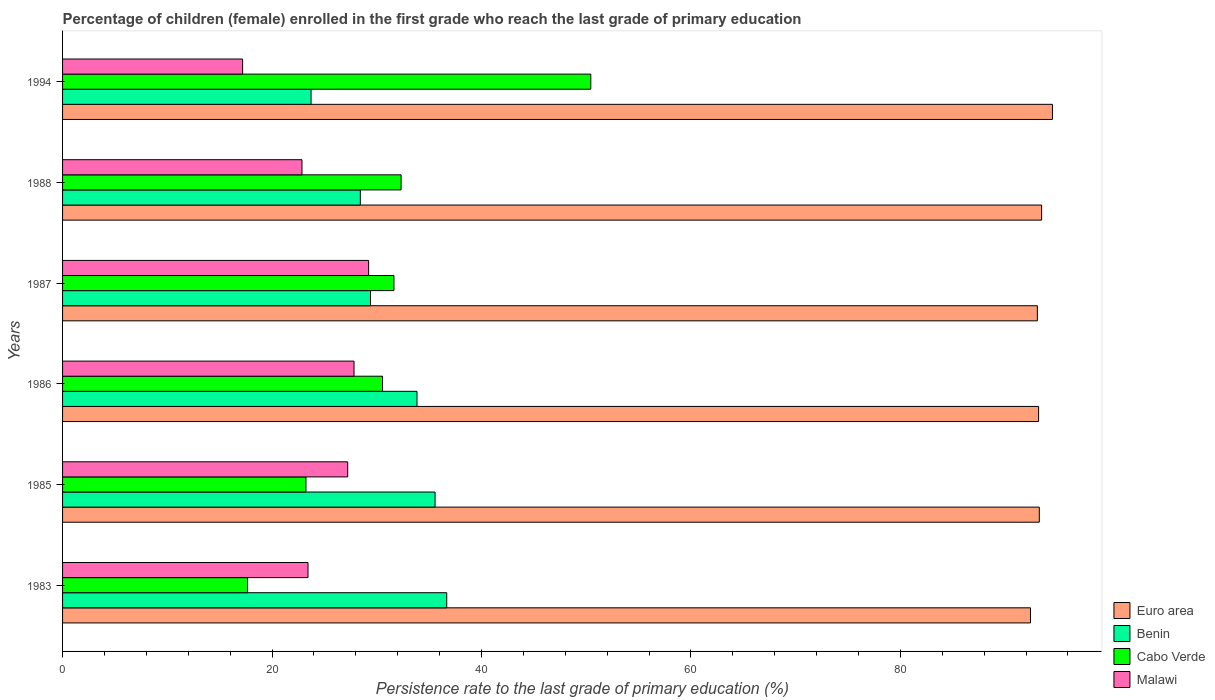How many different coloured bars are there?
Offer a very short reply. 4. How many groups of bars are there?
Ensure brevity in your answer.  6. Are the number of bars on each tick of the Y-axis equal?
Give a very brief answer. Yes. How many bars are there on the 2nd tick from the top?
Your response must be concise. 4. What is the persistence rate of children in Malawi in 1985?
Offer a terse response. 27.23. Across all years, what is the maximum persistence rate of children in Cabo Verde?
Your response must be concise. 50.44. Across all years, what is the minimum persistence rate of children in Euro area?
Offer a terse response. 92.42. In which year was the persistence rate of children in Cabo Verde maximum?
Provide a succinct answer. 1994. In which year was the persistence rate of children in Cabo Verde minimum?
Keep it short and to the point. 1983. What is the total persistence rate of children in Malawi in the graph?
Give a very brief answer. 147.78. What is the difference between the persistence rate of children in Benin in 1987 and that in 1994?
Your response must be concise. 5.67. What is the difference between the persistence rate of children in Cabo Verde in 1994 and the persistence rate of children in Euro area in 1986?
Your answer should be very brief. -42.76. What is the average persistence rate of children in Euro area per year?
Your response must be concise. 93.33. In the year 1994, what is the difference between the persistence rate of children in Malawi and persistence rate of children in Cabo Verde?
Your answer should be very brief. -33.25. What is the ratio of the persistence rate of children in Euro area in 1983 to that in 1987?
Make the answer very short. 0.99. Is the persistence rate of children in Malawi in 1983 less than that in 1986?
Provide a succinct answer. Yes. What is the difference between the highest and the second highest persistence rate of children in Benin?
Offer a very short reply. 1.11. What is the difference between the highest and the lowest persistence rate of children in Malawi?
Keep it short and to the point. 12.03. Is it the case that in every year, the sum of the persistence rate of children in Cabo Verde and persistence rate of children in Benin is greater than the sum of persistence rate of children in Euro area and persistence rate of children in Malawi?
Keep it short and to the point. No. What does the 2nd bar from the top in 1987 represents?
Your answer should be very brief. Cabo Verde. What does the 2nd bar from the bottom in 1986 represents?
Offer a very short reply. Benin. How many bars are there?
Ensure brevity in your answer.  24. Does the graph contain any zero values?
Your answer should be compact. No. Does the graph contain grids?
Provide a succinct answer. No. How many legend labels are there?
Provide a succinct answer. 4. How are the legend labels stacked?
Offer a very short reply. Vertical. What is the title of the graph?
Give a very brief answer. Percentage of children (female) enrolled in the first grade who reach the last grade of primary education. Does "St. Kitts and Nevis" appear as one of the legend labels in the graph?
Offer a terse response. No. What is the label or title of the X-axis?
Ensure brevity in your answer.  Persistence rate to the last grade of primary education (%). What is the label or title of the Y-axis?
Your response must be concise. Years. What is the Persistence rate to the last grade of primary education (%) of Euro area in 1983?
Ensure brevity in your answer.  92.42. What is the Persistence rate to the last grade of primary education (%) of Benin in 1983?
Provide a succinct answer. 36.68. What is the Persistence rate to the last grade of primary education (%) of Cabo Verde in 1983?
Provide a short and direct response. 17.66. What is the Persistence rate to the last grade of primary education (%) in Malawi in 1983?
Ensure brevity in your answer.  23.44. What is the Persistence rate to the last grade of primary education (%) of Euro area in 1985?
Keep it short and to the point. 93.26. What is the Persistence rate to the last grade of primary education (%) of Benin in 1985?
Your answer should be very brief. 35.57. What is the Persistence rate to the last grade of primary education (%) in Cabo Verde in 1985?
Your answer should be compact. 23.24. What is the Persistence rate to the last grade of primary education (%) of Malawi in 1985?
Provide a succinct answer. 27.23. What is the Persistence rate to the last grade of primary education (%) of Euro area in 1986?
Offer a very short reply. 93.2. What is the Persistence rate to the last grade of primary education (%) of Benin in 1986?
Provide a short and direct response. 33.84. What is the Persistence rate to the last grade of primary education (%) in Cabo Verde in 1986?
Your response must be concise. 30.55. What is the Persistence rate to the last grade of primary education (%) of Malawi in 1986?
Your answer should be very brief. 27.83. What is the Persistence rate to the last grade of primary education (%) of Euro area in 1987?
Your answer should be compact. 93.08. What is the Persistence rate to the last grade of primary education (%) in Benin in 1987?
Offer a terse response. 29.4. What is the Persistence rate to the last grade of primary education (%) of Cabo Verde in 1987?
Your response must be concise. 31.64. What is the Persistence rate to the last grade of primary education (%) in Malawi in 1987?
Ensure brevity in your answer.  29.23. What is the Persistence rate to the last grade of primary education (%) in Euro area in 1988?
Keep it short and to the point. 93.49. What is the Persistence rate to the last grade of primary education (%) of Benin in 1988?
Provide a succinct answer. 28.43. What is the Persistence rate to the last grade of primary education (%) in Cabo Verde in 1988?
Offer a very short reply. 32.32. What is the Persistence rate to the last grade of primary education (%) of Malawi in 1988?
Give a very brief answer. 22.86. What is the Persistence rate to the last grade of primary education (%) in Euro area in 1994?
Make the answer very short. 94.52. What is the Persistence rate to the last grade of primary education (%) in Benin in 1994?
Offer a terse response. 23.73. What is the Persistence rate to the last grade of primary education (%) of Cabo Verde in 1994?
Offer a very short reply. 50.44. What is the Persistence rate to the last grade of primary education (%) in Malawi in 1994?
Keep it short and to the point. 17.19. Across all years, what is the maximum Persistence rate to the last grade of primary education (%) in Euro area?
Make the answer very short. 94.52. Across all years, what is the maximum Persistence rate to the last grade of primary education (%) in Benin?
Your response must be concise. 36.68. Across all years, what is the maximum Persistence rate to the last grade of primary education (%) in Cabo Verde?
Keep it short and to the point. 50.44. Across all years, what is the maximum Persistence rate to the last grade of primary education (%) of Malawi?
Provide a succinct answer. 29.23. Across all years, what is the minimum Persistence rate to the last grade of primary education (%) of Euro area?
Offer a terse response. 92.42. Across all years, what is the minimum Persistence rate to the last grade of primary education (%) in Benin?
Your response must be concise. 23.73. Across all years, what is the minimum Persistence rate to the last grade of primary education (%) in Cabo Verde?
Ensure brevity in your answer.  17.66. Across all years, what is the minimum Persistence rate to the last grade of primary education (%) in Malawi?
Your response must be concise. 17.19. What is the total Persistence rate to the last grade of primary education (%) in Euro area in the graph?
Offer a terse response. 559.98. What is the total Persistence rate to the last grade of primary education (%) of Benin in the graph?
Keep it short and to the point. 187.66. What is the total Persistence rate to the last grade of primary education (%) of Cabo Verde in the graph?
Give a very brief answer. 185.86. What is the total Persistence rate to the last grade of primary education (%) in Malawi in the graph?
Ensure brevity in your answer.  147.78. What is the difference between the Persistence rate to the last grade of primary education (%) in Euro area in 1983 and that in 1985?
Provide a succinct answer. -0.84. What is the difference between the Persistence rate to the last grade of primary education (%) of Benin in 1983 and that in 1985?
Your answer should be very brief. 1.11. What is the difference between the Persistence rate to the last grade of primary education (%) in Cabo Verde in 1983 and that in 1985?
Provide a succinct answer. -5.58. What is the difference between the Persistence rate to the last grade of primary education (%) of Malawi in 1983 and that in 1985?
Offer a terse response. -3.79. What is the difference between the Persistence rate to the last grade of primary education (%) in Euro area in 1983 and that in 1986?
Offer a very short reply. -0.78. What is the difference between the Persistence rate to the last grade of primary education (%) of Benin in 1983 and that in 1986?
Offer a very short reply. 2.84. What is the difference between the Persistence rate to the last grade of primary education (%) in Cabo Verde in 1983 and that in 1986?
Offer a terse response. -12.89. What is the difference between the Persistence rate to the last grade of primary education (%) of Malawi in 1983 and that in 1986?
Provide a short and direct response. -4.39. What is the difference between the Persistence rate to the last grade of primary education (%) in Euro area in 1983 and that in 1987?
Keep it short and to the point. -0.66. What is the difference between the Persistence rate to the last grade of primary education (%) of Benin in 1983 and that in 1987?
Your answer should be compact. 7.28. What is the difference between the Persistence rate to the last grade of primary education (%) of Cabo Verde in 1983 and that in 1987?
Offer a terse response. -13.98. What is the difference between the Persistence rate to the last grade of primary education (%) in Malawi in 1983 and that in 1987?
Keep it short and to the point. -5.79. What is the difference between the Persistence rate to the last grade of primary education (%) in Euro area in 1983 and that in 1988?
Offer a terse response. -1.06. What is the difference between the Persistence rate to the last grade of primary education (%) in Benin in 1983 and that in 1988?
Give a very brief answer. 8.25. What is the difference between the Persistence rate to the last grade of primary education (%) of Cabo Verde in 1983 and that in 1988?
Provide a short and direct response. -14.66. What is the difference between the Persistence rate to the last grade of primary education (%) of Malawi in 1983 and that in 1988?
Keep it short and to the point. 0.58. What is the difference between the Persistence rate to the last grade of primary education (%) of Euro area in 1983 and that in 1994?
Give a very brief answer. -2.1. What is the difference between the Persistence rate to the last grade of primary education (%) in Benin in 1983 and that in 1994?
Ensure brevity in your answer.  12.96. What is the difference between the Persistence rate to the last grade of primary education (%) of Cabo Verde in 1983 and that in 1994?
Provide a succinct answer. -32.78. What is the difference between the Persistence rate to the last grade of primary education (%) of Malawi in 1983 and that in 1994?
Provide a short and direct response. 6.25. What is the difference between the Persistence rate to the last grade of primary education (%) of Euro area in 1985 and that in 1986?
Ensure brevity in your answer.  0.07. What is the difference between the Persistence rate to the last grade of primary education (%) in Benin in 1985 and that in 1986?
Your answer should be compact. 1.73. What is the difference between the Persistence rate to the last grade of primary education (%) of Cabo Verde in 1985 and that in 1986?
Your answer should be very brief. -7.31. What is the difference between the Persistence rate to the last grade of primary education (%) of Malawi in 1985 and that in 1986?
Ensure brevity in your answer.  -0.6. What is the difference between the Persistence rate to the last grade of primary education (%) in Euro area in 1985 and that in 1987?
Provide a succinct answer. 0.18. What is the difference between the Persistence rate to the last grade of primary education (%) in Benin in 1985 and that in 1987?
Offer a very short reply. 6.17. What is the difference between the Persistence rate to the last grade of primary education (%) of Cabo Verde in 1985 and that in 1987?
Provide a short and direct response. -8.4. What is the difference between the Persistence rate to the last grade of primary education (%) of Malawi in 1985 and that in 1987?
Make the answer very short. -2. What is the difference between the Persistence rate to the last grade of primary education (%) in Euro area in 1985 and that in 1988?
Your answer should be compact. -0.22. What is the difference between the Persistence rate to the last grade of primary education (%) in Benin in 1985 and that in 1988?
Keep it short and to the point. 7.14. What is the difference between the Persistence rate to the last grade of primary education (%) in Cabo Verde in 1985 and that in 1988?
Keep it short and to the point. -9.08. What is the difference between the Persistence rate to the last grade of primary education (%) in Malawi in 1985 and that in 1988?
Offer a terse response. 4.37. What is the difference between the Persistence rate to the last grade of primary education (%) in Euro area in 1985 and that in 1994?
Provide a short and direct response. -1.26. What is the difference between the Persistence rate to the last grade of primary education (%) of Benin in 1985 and that in 1994?
Your answer should be very brief. 11.84. What is the difference between the Persistence rate to the last grade of primary education (%) of Cabo Verde in 1985 and that in 1994?
Make the answer very short. -27.2. What is the difference between the Persistence rate to the last grade of primary education (%) of Malawi in 1985 and that in 1994?
Make the answer very short. 10.03. What is the difference between the Persistence rate to the last grade of primary education (%) of Euro area in 1986 and that in 1987?
Ensure brevity in your answer.  0.12. What is the difference between the Persistence rate to the last grade of primary education (%) in Benin in 1986 and that in 1987?
Ensure brevity in your answer.  4.44. What is the difference between the Persistence rate to the last grade of primary education (%) in Cabo Verde in 1986 and that in 1987?
Keep it short and to the point. -1.09. What is the difference between the Persistence rate to the last grade of primary education (%) of Malawi in 1986 and that in 1987?
Provide a short and direct response. -1.39. What is the difference between the Persistence rate to the last grade of primary education (%) of Euro area in 1986 and that in 1988?
Offer a very short reply. -0.29. What is the difference between the Persistence rate to the last grade of primary education (%) of Benin in 1986 and that in 1988?
Provide a short and direct response. 5.41. What is the difference between the Persistence rate to the last grade of primary education (%) of Cabo Verde in 1986 and that in 1988?
Ensure brevity in your answer.  -1.77. What is the difference between the Persistence rate to the last grade of primary education (%) of Malawi in 1986 and that in 1988?
Ensure brevity in your answer.  4.97. What is the difference between the Persistence rate to the last grade of primary education (%) of Euro area in 1986 and that in 1994?
Give a very brief answer. -1.32. What is the difference between the Persistence rate to the last grade of primary education (%) of Benin in 1986 and that in 1994?
Your answer should be very brief. 10.12. What is the difference between the Persistence rate to the last grade of primary education (%) of Cabo Verde in 1986 and that in 1994?
Give a very brief answer. -19.89. What is the difference between the Persistence rate to the last grade of primary education (%) of Malawi in 1986 and that in 1994?
Give a very brief answer. 10.64. What is the difference between the Persistence rate to the last grade of primary education (%) in Euro area in 1987 and that in 1988?
Your answer should be compact. -0.41. What is the difference between the Persistence rate to the last grade of primary education (%) in Cabo Verde in 1987 and that in 1988?
Keep it short and to the point. -0.68. What is the difference between the Persistence rate to the last grade of primary education (%) in Malawi in 1987 and that in 1988?
Provide a succinct answer. 6.36. What is the difference between the Persistence rate to the last grade of primary education (%) of Euro area in 1987 and that in 1994?
Ensure brevity in your answer.  -1.44. What is the difference between the Persistence rate to the last grade of primary education (%) of Benin in 1987 and that in 1994?
Provide a succinct answer. 5.67. What is the difference between the Persistence rate to the last grade of primary education (%) of Cabo Verde in 1987 and that in 1994?
Your answer should be compact. -18.8. What is the difference between the Persistence rate to the last grade of primary education (%) of Malawi in 1987 and that in 1994?
Ensure brevity in your answer.  12.03. What is the difference between the Persistence rate to the last grade of primary education (%) in Euro area in 1988 and that in 1994?
Offer a very short reply. -1.03. What is the difference between the Persistence rate to the last grade of primary education (%) of Benin in 1988 and that in 1994?
Offer a very short reply. 4.71. What is the difference between the Persistence rate to the last grade of primary education (%) of Cabo Verde in 1988 and that in 1994?
Provide a succinct answer. -18.12. What is the difference between the Persistence rate to the last grade of primary education (%) in Malawi in 1988 and that in 1994?
Offer a very short reply. 5.67. What is the difference between the Persistence rate to the last grade of primary education (%) in Euro area in 1983 and the Persistence rate to the last grade of primary education (%) in Benin in 1985?
Keep it short and to the point. 56.85. What is the difference between the Persistence rate to the last grade of primary education (%) in Euro area in 1983 and the Persistence rate to the last grade of primary education (%) in Cabo Verde in 1985?
Your answer should be very brief. 69.18. What is the difference between the Persistence rate to the last grade of primary education (%) of Euro area in 1983 and the Persistence rate to the last grade of primary education (%) of Malawi in 1985?
Make the answer very short. 65.2. What is the difference between the Persistence rate to the last grade of primary education (%) in Benin in 1983 and the Persistence rate to the last grade of primary education (%) in Cabo Verde in 1985?
Make the answer very short. 13.44. What is the difference between the Persistence rate to the last grade of primary education (%) of Benin in 1983 and the Persistence rate to the last grade of primary education (%) of Malawi in 1985?
Keep it short and to the point. 9.46. What is the difference between the Persistence rate to the last grade of primary education (%) in Cabo Verde in 1983 and the Persistence rate to the last grade of primary education (%) in Malawi in 1985?
Ensure brevity in your answer.  -9.56. What is the difference between the Persistence rate to the last grade of primary education (%) in Euro area in 1983 and the Persistence rate to the last grade of primary education (%) in Benin in 1986?
Ensure brevity in your answer.  58.58. What is the difference between the Persistence rate to the last grade of primary education (%) of Euro area in 1983 and the Persistence rate to the last grade of primary education (%) of Cabo Verde in 1986?
Provide a short and direct response. 61.87. What is the difference between the Persistence rate to the last grade of primary education (%) of Euro area in 1983 and the Persistence rate to the last grade of primary education (%) of Malawi in 1986?
Your answer should be compact. 64.59. What is the difference between the Persistence rate to the last grade of primary education (%) of Benin in 1983 and the Persistence rate to the last grade of primary education (%) of Cabo Verde in 1986?
Provide a short and direct response. 6.13. What is the difference between the Persistence rate to the last grade of primary education (%) in Benin in 1983 and the Persistence rate to the last grade of primary education (%) in Malawi in 1986?
Make the answer very short. 8.85. What is the difference between the Persistence rate to the last grade of primary education (%) of Cabo Verde in 1983 and the Persistence rate to the last grade of primary education (%) of Malawi in 1986?
Ensure brevity in your answer.  -10.17. What is the difference between the Persistence rate to the last grade of primary education (%) of Euro area in 1983 and the Persistence rate to the last grade of primary education (%) of Benin in 1987?
Offer a very short reply. 63.02. What is the difference between the Persistence rate to the last grade of primary education (%) of Euro area in 1983 and the Persistence rate to the last grade of primary education (%) of Cabo Verde in 1987?
Give a very brief answer. 60.78. What is the difference between the Persistence rate to the last grade of primary education (%) of Euro area in 1983 and the Persistence rate to the last grade of primary education (%) of Malawi in 1987?
Ensure brevity in your answer.  63.2. What is the difference between the Persistence rate to the last grade of primary education (%) of Benin in 1983 and the Persistence rate to the last grade of primary education (%) of Cabo Verde in 1987?
Ensure brevity in your answer.  5.04. What is the difference between the Persistence rate to the last grade of primary education (%) in Benin in 1983 and the Persistence rate to the last grade of primary education (%) in Malawi in 1987?
Provide a succinct answer. 7.46. What is the difference between the Persistence rate to the last grade of primary education (%) of Cabo Verde in 1983 and the Persistence rate to the last grade of primary education (%) of Malawi in 1987?
Offer a very short reply. -11.56. What is the difference between the Persistence rate to the last grade of primary education (%) in Euro area in 1983 and the Persistence rate to the last grade of primary education (%) in Benin in 1988?
Provide a short and direct response. 63.99. What is the difference between the Persistence rate to the last grade of primary education (%) of Euro area in 1983 and the Persistence rate to the last grade of primary education (%) of Cabo Verde in 1988?
Your answer should be very brief. 60.1. What is the difference between the Persistence rate to the last grade of primary education (%) of Euro area in 1983 and the Persistence rate to the last grade of primary education (%) of Malawi in 1988?
Keep it short and to the point. 69.56. What is the difference between the Persistence rate to the last grade of primary education (%) in Benin in 1983 and the Persistence rate to the last grade of primary education (%) in Cabo Verde in 1988?
Keep it short and to the point. 4.36. What is the difference between the Persistence rate to the last grade of primary education (%) in Benin in 1983 and the Persistence rate to the last grade of primary education (%) in Malawi in 1988?
Make the answer very short. 13.82. What is the difference between the Persistence rate to the last grade of primary education (%) in Cabo Verde in 1983 and the Persistence rate to the last grade of primary education (%) in Malawi in 1988?
Provide a short and direct response. -5.2. What is the difference between the Persistence rate to the last grade of primary education (%) of Euro area in 1983 and the Persistence rate to the last grade of primary education (%) of Benin in 1994?
Provide a succinct answer. 68.7. What is the difference between the Persistence rate to the last grade of primary education (%) in Euro area in 1983 and the Persistence rate to the last grade of primary education (%) in Cabo Verde in 1994?
Offer a very short reply. 41.98. What is the difference between the Persistence rate to the last grade of primary education (%) of Euro area in 1983 and the Persistence rate to the last grade of primary education (%) of Malawi in 1994?
Give a very brief answer. 75.23. What is the difference between the Persistence rate to the last grade of primary education (%) in Benin in 1983 and the Persistence rate to the last grade of primary education (%) in Cabo Verde in 1994?
Give a very brief answer. -13.76. What is the difference between the Persistence rate to the last grade of primary education (%) of Benin in 1983 and the Persistence rate to the last grade of primary education (%) of Malawi in 1994?
Offer a terse response. 19.49. What is the difference between the Persistence rate to the last grade of primary education (%) in Cabo Verde in 1983 and the Persistence rate to the last grade of primary education (%) in Malawi in 1994?
Give a very brief answer. 0.47. What is the difference between the Persistence rate to the last grade of primary education (%) of Euro area in 1985 and the Persistence rate to the last grade of primary education (%) of Benin in 1986?
Keep it short and to the point. 59.42. What is the difference between the Persistence rate to the last grade of primary education (%) of Euro area in 1985 and the Persistence rate to the last grade of primary education (%) of Cabo Verde in 1986?
Provide a succinct answer. 62.71. What is the difference between the Persistence rate to the last grade of primary education (%) of Euro area in 1985 and the Persistence rate to the last grade of primary education (%) of Malawi in 1986?
Provide a short and direct response. 65.43. What is the difference between the Persistence rate to the last grade of primary education (%) in Benin in 1985 and the Persistence rate to the last grade of primary education (%) in Cabo Verde in 1986?
Your answer should be compact. 5.02. What is the difference between the Persistence rate to the last grade of primary education (%) in Benin in 1985 and the Persistence rate to the last grade of primary education (%) in Malawi in 1986?
Offer a terse response. 7.74. What is the difference between the Persistence rate to the last grade of primary education (%) in Cabo Verde in 1985 and the Persistence rate to the last grade of primary education (%) in Malawi in 1986?
Give a very brief answer. -4.59. What is the difference between the Persistence rate to the last grade of primary education (%) of Euro area in 1985 and the Persistence rate to the last grade of primary education (%) of Benin in 1987?
Your answer should be compact. 63.86. What is the difference between the Persistence rate to the last grade of primary education (%) in Euro area in 1985 and the Persistence rate to the last grade of primary education (%) in Cabo Verde in 1987?
Offer a very short reply. 61.62. What is the difference between the Persistence rate to the last grade of primary education (%) of Euro area in 1985 and the Persistence rate to the last grade of primary education (%) of Malawi in 1987?
Offer a very short reply. 64.04. What is the difference between the Persistence rate to the last grade of primary education (%) in Benin in 1985 and the Persistence rate to the last grade of primary education (%) in Cabo Verde in 1987?
Your answer should be very brief. 3.93. What is the difference between the Persistence rate to the last grade of primary education (%) of Benin in 1985 and the Persistence rate to the last grade of primary education (%) of Malawi in 1987?
Provide a short and direct response. 6.34. What is the difference between the Persistence rate to the last grade of primary education (%) in Cabo Verde in 1985 and the Persistence rate to the last grade of primary education (%) in Malawi in 1987?
Offer a terse response. -5.98. What is the difference between the Persistence rate to the last grade of primary education (%) of Euro area in 1985 and the Persistence rate to the last grade of primary education (%) of Benin in 1988?
Provide a short and direct response. 64.83. What is the difference between the Persistence rate to the last grade of primary education (%) of Euro area in 1985 and the Persistence rate to the last grade of primary education (%) of Cabo Verde in 1988?
Your answer should be very brief. 60.94. What is the difference between the Persistence rate to the last grade of primary education (%) in Euro area in 1985 and the Persistence rate to the last grade of primary education (%) in Malawi in 1988?
Make the answer very short. 70.4. What is the difference between the Persistence rate to the last grade of primary education (%) in Benin in 1985 and the Persistence rate to the last grade of primary education (%) in Cabo Verde in 1988?
Make the answer very short. 3.25. What is the difference between the Persistence rate to the last grade of primary education (%) of Benin in 1985 and the Persistence rate to the last grade of primary education (%) of Malawi in 1988?
Offer a terse response. 12.71. What is the difference between the Persistence rate to the last grade of primary education (%) of Cabo Verde in 1985 and the Persistence rate to the last grade of primary education (%) of Malawi in 1988?
Offer a very short reply. 0.38. What is the difference between the Persistence rate to the last grade of primary education (%) of Euro area in 1985 and the Persistence rate to the last grade of primary education (%) of Benin in 1994?
Your answer should be very brief. 69.54. What is the difference between the Persistence rate to the last grade of primary education (%) in Euro area in 1985 and the Persistence rate to the last grade of primary education (%) in Cabo Verde in 1994?
Keep it short and to the point. 42.83. What is the difference between the Persistence rate to the last grade of primary education (%) of Euro area in 1985 and the Persistence rate to the last grade of primary education (%) of Malawi in 1994?
Make the answer very short. 76.07. What is the difference between the Persistence rate to the last grade of primary education (%) in Benin in 1985 and the Persistence rate to the last grade of primary education (%) in Cabo Verde in 1994?
Give a very brief answer. -14.87. What is the difference between the Persistence rate to the last grade of primary education (%) of Benin in 1985 and the Persistence rate to the last grade of primary education (%) of Malawi in 1994?
Your response must be concise. 18.38. What is the difference between the Persistence rate to the last grade of primary education (%) of Cabo Verde in 1985 and the Persistence rate to the last grade of primary education (%) of Malawi in 1994?
Offer a terse response. 6.05. What is the difference between the Persistence rate to the last grade of primary education (%) of Euro area in 1986 and the Persistence rate to the last grade of primary education (%) of Benin in 1987?
Your response must be concise. 63.8. What is the difference between the Persistence rate to the last grade of primary education (%) of Euro area in 1986 and the Persistence rate to the last grade of primary education (%) of Cabo Verde in 1987?
Keep it short and to the point. 61.56. What is the difference between the Persistence rate to the last grade of primary education (%) of Euro area in 1986 and the Persistence rate to the last grade of primary education (%) of Malawi in 1987?
Your response must be concise. 63.97. What is the difference between the Persistence rate to the last grade of primary education (%) of Benin in 1986 and the Persistence rate to the last grade of primary education (%) of Cabo Verde in 1987?
Provide a short and direct response. 2.2. What is the difference between the Persistence rate to the last grade of primary education (%) in Benin in 1986 and the Persistence rate to the last grade of primary education (%) in Malawi in 1987?
Make the answer very short. 4.62. What is the difference between the Persistence rate to the last grade of primary education (%) of Cabo Verde in 1986 and the Persistence rate to the last grade of primary education (%) of Malawi in 1987?
Offer a very short reply. 1.33. What is the difference between the Persistence rate to the last grade of primary education (%) in Euro area in 1986 and the Persistence rate to the last grade of primary education (%) in Benin in 1988?
Provide a succinct answer. 64.77. What is the difference between the Persistence rate to the last grade of primary education (%) of Euro area in 1986 and the Persistence rate to the last grade of primary education (%) of Cabo Verde in 1988?
Offer a very short reply. 60.88. What is the difference between the Persistence rate to the last grade of primary education (%) in Euro area in 1986 and the Persistence rate to the last grade of primary education (%) in Malawi in 1988?
Your answer should be very brief. 70.34. What is the difference between the Persistence rate to the last grade of primary education (%) of Benin in 1986 and the Persistence rate to the last grade of primary education (%) of Cabo Verde in 1988?
Provide a short and direct response. 1.52. What is the difference between the Persistence rate to the last grade of primary education (%) of Benin in 1986 and the Persistence rate to the last grade of primary education (%) of Malawi in 1988?
Provide a succinct answer. 10.98. What is the difference between the Persistence rate to the last grade of primary education (%) of Cabo Verde in 1986 and the Persistence rate to the last grade of primary education (%) of Malawi in 1988?
Provide a succinct answer. 7.69. What is the difference between the Persistence rate to the last grade of primary education (%) in Euro area in 1986 and the Persistence rate to the last grade of primary education (%) in Benin in 1994?
Ensure brevity in your answer.  69.47. What is the difference between the Persistence rate to the last grade of primary education (%) in Euro area in 1986 and the Persistence rate to the last grade of primary education (%) in Cabo Verde in 1994?
Offer a terse response. 42.76. What is the difference between the Persistence rate to the last grade of primary education (%) in Euro area in 1986 and the Persistence rate to the last grade of primary education (%) in Malawi in 1994?
Your answer should be very brief. 76.01. What is the difference between the Persistence rate to the last grade of primary education (%) of Benin in 1986 and the Persistence rate to the last grade of primary education (%) of Cabo Verde in 1994?
Provide a succinct answer. -16.6. What is the difference between the Persistence rate to the last grade of primary education (%) of Benin in 1986 and the Persistence rate to the last grade of primary education (%) of Malawi in 1994?
Give a very brief answer. 16.65. What is the difference between the Persistence rate to the last grade of primary education (%) in Cabo Verde in 1986 and the Persistence rate to the last grade of primary education (%) in Malawi in 1994?
Keep it short and to the point. 13.36. What is the difference between the Persistence rate to the last grade of primary education (%) of Euro area in 1987 and the Persistence rate to the last grade of primary education (%) of Benin in 1988?
Your answer should be compact. 64.65. What is the difference between the Persistence rate to the last grade of primary education (%) of Euro area in 1987 and the Persistence rate to the last grade of primary education (%) of Cabo Verde in 1988?
Ensure brevity in your answer.  60.76. What is the difference between the Persistence rate to the last grade of primary education (%) in Euro area in 1987 and the Persistence rate to the last grade of primary education (%) in Malawi in 1988?
Your response must be concise. 70.22. What is the difference between the Persistence rate to the last grade of primary education (%) in Benin in 1987 and the Persistence rate to the last grade of primary education (%) in Cabo Verde in 1988?
Your response must be concise. -2.92. What is the difference between the Persistence rate to the last grade of primary education (%) of Benin in 1987 and the Persistence rate to the last grade of primary education (%) of Malawi in 1988?
Keep it short and to the point. 6.54. What is the difference between the Persistence rate to the last grade of primary education (%) of Cabo Verde in 1987 and the Persistence rate to the last grade of primary education (%) of Malawi in 1988?
Your answer should be compact. 8.78. What is the difference between the Persistence rate to the last grade of primary education (%) of Euro area in 1987 and the Persistence rate to the last grade of primary education (%) of Benin in 1994?
Offer a terse response. 69.35. What is the difference between the Persistence rate to the last grade of primary education (%) of Euro area in 1987 and the Persistence rate to the last grade of primary education (%) of Cabo Verde in 1994?
Your response must be concise. 42.64. What is the difference between the Persistence rate to the last grade of primary education (%) in Euro area in 1987 and the Persistence rate to the last grade of primary education (%) in Malawi in 1994?
Offer a very short reply. 75.89. What is the difference between the Persistence rate to the last grade of primary education (%) in Benin in 1987 and the Persistence rate to the last grade of primary education (%) in Cabo Verde in 1994?
Your answer should be very brief. -21.04. What is the difference between the Persistence rate to the last grade of primary education (%) of Benin in 1987 and the Persistence rate to the last grade of primary education (%) of Malawi in 1994?
Your answer should be very brief. 12.21. What is the difference between the Persistence rate to the last grade of primary education (%) in Cabo Verde in 1987 and the Persistence rate to the last grade of primary education (%) in Malawi in 1994?
Your response must be concise. 14.45. What is the difference between the Persistence rate to the last grade of primary education (%) in Euro area in 1988 and the Persistence rate to the last grade of primary education (%) in Benin in 1994?
Your response must be concise. 69.76. What is the difference between the Persistence rate to the last grade of primary education (%) of Euro area in 1988 and the Persistence rate to the last grade of primary education (%) of Cabo Verde in 1994?
Keep it short and to the point. 43.05. What is the difference between the Persistence rate to the last grade of primary education (%) of Euro area in 1988 and the Persistence rate to the last grade of primary education (%) of Malawi in 1994?
Offer a terse response. 76.3. What is the difference between the Persistence rate to the last grade of primary education (%) in Benin in 1988 and the Persistence rate to the last grade of primary education (%) in Cabo Verde in 1994?
Keep it short and to the point. -22.01. What is the difference between the Persistence rate to the last grade of primary education (%) of Benin in 1988 and the Persistence rate to the last grade of primary education (%) of Malawi in 1994?
Your answer should be compact. 11.24. What is the difference between the Persistence rate to the last grade of primary education (%) in Cabo Verde in 1988 and the Persistence rate to the last grade of primary education (%) in Malawi in 1994?
Offer a terse response. 15.13. What is the average Persistence rate to the last grade of primary education (%) of Euro area per year?
Your answer should be very brief. 93.33. What is the average Persistence rate to the last grade of primary education (%) in Benin per year?
Your response must be concise. 31.28. What is the average Persistence rate to the last grade of primary education (%) of Cabo Verde per year?
Give a very brief answer. 30.98. What is the average Persistence rate to the last grade of primary education (%) of Malawi per year?
Give a very brief answer. 24.63. In the year 1983, what is the difference between the Persistence rate to the last grade of primary education (%) in Euro area and Persistence rate to the last grade of primary education (%) in Benin?
Offer a very short reply. 55.74. In the year 1983, what is the difference between the Persistence rate to the last grade of primary education (%) of Euro area and Persistence rate to the last grade of primary education (%) of Cabo Verde?
Your answer should be very brief. 74.76. In the year 1983, what is the difference between the Persistence rate to the last grade of primary education (%) of Euro area and Persistence rate to the last grade of primary education (%) of Malawi?
Your answer should be very brief. 68.99. In the year 1983, what is the difference between the Persistence rate to the last grade of primary education (%) of Benin and Persistence rate to the last grade of primary education (%) of Cabo Verde?
Offer a terse response. 19.02. In the year 1983, what is the difference between the Persistence rate to the last grade of primary education (%) in Benin and Persistence rate to the last grade of primary education (%) in Malawi?
Your answer should be very brief. 13.25. In the year 1983, what is the difference between the Persistence rate to the last grade of primary education (%) in Cabo Verde and Persistence rate to the last grade of primary education (%) in Malawi?
Give a very brief answer. -5.77. In the year 1985, what is the difference between the Persistence rate to the last grade of primary education (%) of Euro area and Persistence rate to the last grade of primary education (%) of Benin?
Offer a very short reply. 57.69. In the year 1985, what is the difference between the Persistence rate to the last grade of primary education (%) of Euro area and Persistence rate to the last grade of primary education (%) of Cabo Verde?
Provide a succinct answer. 70.02. In the year 1985, what is the difference between the Persistence rate to the last grade of primary education (%) in Euro area and Persistence rate to the last grade of primary education (%) in Malawi?
Provide a succinct answer. 66.04. In the year 1985, what is the difference between the Persistence rate to the last grade of primary education (%) in Benin and Persistence rate to the last grade of primary education (%) in Cabo Verde?
Make the answer very short. 12.33. In the year 1985, what is the difference between the Persistence rate to the last grade of primary education (%) of Benin and Persistence rate to the last grade of primary education (%) of Malawi?
Your answer should be very brief. 8.34. In the year 1985, what is the difference between the Persistence rate to the last grade of primary education (%) in Cabo Verde and Persistence rate to the last grade of primary education (%) in Malawi?
Ensure brevity in your answer.  -3.99. In the year 1986, what is the difference between the Persistence rate to the last grade of primary education (%) in Euro area and Persistence rate to the last grade of primary education (%) in Benin?
Provide a succinct answer. 59.36. In the year 1986, what is the difference between the Persistence rate to the last grade of primary education (%) of Euro area and Persistence rate to the last grade of primary education (%) of Cabo Verde?
Make the answer very short. 62.65. In the year 1986, what is the difference between the Persistence rate to the last grade of primary education (%) of Euro area and Persistence rate to the last grade of primary education (%) of Malawi?
Offer a very short reply. 65.37. In the year 1986, what is the difference between the Persistence rate to the last grade of primary education (%) of Benin and Persistence rate to the last grade of primary education (%) of Cabo Verde?
Your answer should be compact. 3.29. In the year 1986, what is the difference between the Persistence rate to the last grade of primary education (%) of Benin and Persistence rate to the last grade of primary education (%) of Malawi?
Offer a terse response. 6.01. In the year 1986, what is the difference between the Persistence rate to the last grade of primary education (%) in Cabo Verde and Persistence rate to the last grade of primary education (%) in Malawi?
Provide a succinct answer. 2.72. In the year 1987, what is the difference between the Persistence rate to the last grade of primary education (%) of Euro area and Persistence rate to the last grade of primary education (%) of Benin?
Your response must be concise. 63.68. In the year 1987, what is the difference between the Persistence rate to the last grade of primary education (%) of Euro area and Persistence rate to the last grade of primary education (%) of Cabo Verde?
Your answer should be compact. 61.44. In the year 1987, what is the difference between the Persistence rate to the last grade of primary education (%) of Euro area and Persistence rate to the last grade of primary education (%) of Malawi?
Your response must be concise. 63.85. In the year 1987, what is the difference between the Persistence rate to the last grade of primary education (%) of Benin and Persistence rate to the last grade of primary education (%) of Cabo Verde?
Your answer should be compact. -2.24. In the year 1987, what is the difference between the Persistence rate to the last grade of primary education (%) of Benin and Persistence rate to the last grade of primary education (%) of Malawi?
Offer a very short reply. 0.18. In the year 1987, what is the difference between the Persistence rate to the last grade of primary education (%) of Cabo Verde and Persistence rate to the last grade of primary education (%) of Malawi?
Offer a very short reply. 2.42. In the year 1988, what is the difference between the Persistence rate to the last grade of primary education (%) of Euro area and Persistence rate to the last grade of primary education (%) of Benin?
Provide a short and direct response. 65.05. In the year 1988, what is the difference between the Persistence rate to the last grade of primary education (%) in Euro area and Persistence rate to the last grade of primary education (%) in Cabo Verde?
Make the answer very short. 61.16. In the year 1988, what is the difference between the Persistence rate to the last grade of primary education (%) of Euro area and Persistence rate to the last grade of primary education (%) of Malawi?
Provide a succinct answer. 70.63. In the year 1988, what is the difference between the Persistence rate to the last grade of primary education (%) of Benin and Persistence rate to the last grade of primary education (%) of Cabo Verde?
Provide a succinct answer. -3.89. In the year 1988, what is the difference between the Persistence rate to the last grade of primary education (%) in Benin and Persistence rate to the last grade of primary education (%) in Malawi?
Provide a succinct answer. 5.57. In the year 1988, what is the difference between the Persistence rate to the last grade of primary education (%) in Cabo Verde and Persistence rate to the last grade of primary education (%) in Malawi?
Give a very brief answer. 9.46. In the year 1994, what is the difference between the Persistence rate to the last grade of primary education (%) in Euro area and Persistence rate to the last grade of primary education (%) in Benin?
Ensure brevity in your answer.  70.79. In the year 1994, what is the difference between the Persistence rate to the last grade of primary education (%) of Euro area and Persistence rate to the last grade of primary education (%) of Cabo Verde?
Ensure brevity in your answer.  44.08. In the year 1994, what is the difference between the Persistence rate to the last grade of primary education (%) of Euro area and Persistence rate to the last grade of primary education (%) of Malawi?
Provide a short and direct response. 77.33. In the year 1994, what is the difference between the Persistence rate to the last grade of primary education (%) in Benin and Persistence rate to the last grade of primary education (%) in Cabo Verde?
Provide a short and direct response. -26.71. In the year 1994, what is the difference between the Persistence rate to the last grade of primary education (%) in Benin and Persistence rate to the last grade of primary education (%) in Malawi?
Keep it short and to the point. 6.54. In the year 1994, what is the difference between the Persistence rate to the last grade of primary education (%) of Cabo Verde and Persistence rate to the last grade of primary education (%) of Malawi?
Provide a short and direct response. 33.25. What is the ratio of the Persistence rate to the last grade of primary education (%) of Euro area in 1983 to that in 1985?
Your answer should be compact. 0.99. What is the ratio of the Persistence rate to the last grade of primary education (%) in Benin in 1983 to that in 1985?
Your response must be concise. 1.03. What is the ratio of the Persistence rate to the last grade of primary education (%) of Cabo Verde in 1983 to that in 1985?
Provide a succinct answer. 0.76. What is the ratio of the Persistence rate to the last grade of primary education (%) in Malawi in 1983 to that in 1985?
Offer a terse response. 0.86. What is the ratio of the Persistence rate to the last grade of primary education (%) of Benin in 1983 to that in 1986?
Your answer should be very brief. 1.08. What is the ratio of the Persistence rate to the last grade of primary education (%) of Cabo Verde in 1983 to that in 1986?
Ensure brevity in your answer.  0.58. What is the ratio of the Persistence rate to the last grade of primary education (%) in Malawi in 1983 to that in 1986?
Offer a terse response. 0.84. What is the ratio of the Persistence rate to the last grade of primary education (%) in Benin in 1983 to that in 1987?
Keep it short and to the point. 1.25. What is the ratio of the Persistence rate to the last grade of primary education (%) in Cabo Verde in 1983 to that in 1987?
Ensure brevity in your answer.  0.56. What is the ratio of the Persistence rate to the last grade of primary education (%) in Malawi in 1983 to that in 1987?
Your answer should be very brief. 0.8. What is the ratio of the Persistence rate to the last grade of primary education (%) of Euro area in 1983 to that in 1988?
Keep it short and to the point. 0.99. What is the ratio of the Persistence rate to the last grade of primary education (%) of Benin in 1983 to that in 1988?
Ensure brevity in your answer.  1.29. What is the ratio of the Persistence rate to the last grade of primary education (%) in Cabo Verde in 1983 to that in 1988?
Your answer should be compact. 0.55. What is the ratio of the Persistence rate to the last grade of primary education (%) in Malawi in 1983 to that in 1988?
Your answer should be very brief. 1.03. What is the ratio of the Persistence rate to the last grade of primary education (%) of Euro area in 1983 to that in 1994?
Provide a succinct answer. 0.98. What is the ratio of the Persistence rate to the last grade of primary education (%) of Benin in 1983 to that in 1994?
Ensure brevity in your answer.  1.55. What is the ratio of the Persistence rate to the last grade of primary education (%) in Cabo Verde in 1983 to that in 1994?
Ensure brevity in your answer.  0.35. What is the ratio of the Persistence rate to the last grade of primary education (%) in Malawi in 1983 to that in 1994?
Your response must be concise. 1.36. What is the ratio of the Persistence rate to the last grade of primary education (%) in Benin in 1985 to that in 1986?
Offer a very short reply. 1.05. What is the ratio of the Persistence rate to the last grade of primary education (%) in Cabo Verde in 1985 to that in 1986?
Your answer should be very brief. 0.76. What is the ratio of the Persistence rate to the last grade of primary education (%) in Malawi in 1985 to that in 1986?
Make the answer very short. 0.98. What is the ratio of the Persistence rate to the last grade of primary education (%) in Euro area in 1985 to that in 1987?
Keep it short and to the point. 1. What is the ratio of the Persistence rate to the last grade of primary education (%) of Benin in 1985 to that in 1987?
Give a very brief answer. 1.21. What is the ratio of the Persistence rate to the last grade of primary education (%) of Cabo Verde in 1985 to that in 1987?
Your answer should be very brief. 0.73. What is the ratio of the Persistence rate to the last grade of primary education (%) of Malawi in 1985 to that in 1987?
Your answer should be compact. 0.93. What is the ratio of the Persistence rate to the last grade of primary education (%) of Euro area in 1985 to that in 1988?
Ensure brevity in your answer.  1. What is the ratio of the Persistence rate to the last grade of primary education (%) of Benin in 1985 to that in 1988?
Offer a very short reply. 1.25. What is the ratio of the Persistence rate to the last grade of primary education (%) of Cabo Verde in 1985 to that in 1988?
Keep it short and to the point. 0.72. What is the ratio of the Persistence rate to the last grade of primary education (%) of Malawi in 1985 to that in 1988?
Keep it short and to the point. 1.19. What is the ratio of the Persistence rate to the last grade of primary education (%) in Euro area in 1985 to that in 1994?
Your response must be concise. 0.99. What is the ratio of the Persistence rate to the last grade of primary education (%) of Benin in 1985 to that in 1994?
Make the answer very short. 1.5. What is the ratio of the Persistence rate to the last grade of primary education (%) of Cabo Verde in 1985 to that in 1994?
Your answer should be compact. 0.46. What is the ratio of the Persistence rate to the last grade of primary education (%) in Malawi in 1985 to that in 1994?
Offer a very short reply. 1.58. What is the ratio of the Persistence rate to the last grade of primary education (%) of Benin in 1986 to that in 1987?
Give a very brief answer. 1.15. What is the ratio of the Persistence rate to the last grade of primary education (%) in Cabo Verde in 1986 to that in 1987?
Offer a very short reply. 0.97. What is the ratio of the Persistence rate to the last grade of primary education (%) in Malawi in 1986 to that in 1987?
Provide a succinct answer. 0.95. What is the ratio of the Persistence rate to the last grade of primary education (%) of Benin in 1986 to that in 1988?
Your answer should be very brief. 1.19. What is the ratio of the Persistence rate to the last grade of primary education (%) of Cabo Verde in 1986 to that in 1988?
Your answer should be compact. 0.95. What is the ratio of the Persistence rate to the last grade of primary education (%) in Malawi in 1986 to that in 1988?
Make the answer very short. 1.22. What is the ratio of the Persistence rate to the last grade of primary education (%) in Euro area in 1986 to that in 1994?
Offer a very short reply. 0.99. What is the ratio of the Persistence rate to the last grade of primary education (%) of Benin in 1986 to that in 1994?
Your answer should be compact. 1.43. What is the ratio of the Persistence rate to the last grade of primary education (%) in Cabo Verde in 1986 to that in 1994?
Your answer should be very brief. 0.61. What is the ratio of the Persistence rate to the last grade of primary education (%) of Malawi in 1986 to that in 1994?
Give a very brief answer. 1.62. What is the ratio of the Persistence rate to the last grade of primary education (%) in Euro area in 1987 to that in 1988?
Your answer should be very brief. 1. What is the ratio of the Persistence rate to the last grade of primary education (%) in Benin in 1987 to that in 1988?
Offer a very short reply. 1.03. What is the ratio of the Persistence rate to the last grade of primary education (%) of Cabo Verde in 1987 to that in 1988?
Offer a very short reply. 0.98. What is the ratio of the Persistence rate to the last grade of primary education (%) of Malawi in 1987 to that in 1988?
Ensure brevity in your answer.  1.28. What is the ratio of the Persistence rate to the last grade of primary education (%) of Benin in 1987 to that in 1994?
Provide a short and direct response. 1.24. What is the ratio of the Persistence rate to the last grade of primary education (%) in Cabo Verde in 1987 to that in 1994?
Give a very brief answer. 0.63. What is the ratio of the Persistence rate to the last grade of primary education (%) of Malawi in 1987 to that in 1994?
Make the answer very short. 1.7. What is the ratio of the Persistence rate to the last grade of primary education (%) of Benin in 1988 to that in 1994?
Your response must be concise. 1.2. What is the ratio of the Persistence rate to the last grade of primary education (%) of Cabo Verde in 1988 to that in 1994?
Give a very brief answer. 0.64. What is the ratio of the Persistence rate to the last grade of primary education (%) of Malawi in 1988 to that in 1994?
Your answer should be very brief. 1.33. What is the difference between the highest and the second highest Persistence rate to the last grade of primary education (%) in Euro area?
Ensure brevity in your answer.  1.03. What is the difference between the highest and the second highest Persistence rate to the last grade of primary education (%) in Benin?
Ensure brevity in your answer.  1.11. What is the difference between the highest and the second highest Persistence rate to the last grade of primary education (%) in Cabo Verde?
Keep it short and to the point. 18.12. What is the difference between the highest and the second highest Persistence rate to the last grade of primary education (%) in Malawi?
Offer a terse response. 1.39. What is the difference between the highest and the lowest Persistence rate to the last grade of primary education (%) of Euro area?
Your response must be concise. 2.1. What is the difference between the highest and the lowest Persistence rate to the last grade of primary education (%) of Benin?
Provide a succinct answer. 12.96. What is the difference between the highest and the lowest Persistence rate to the last grade of primary education (%) in Cabo Verde?
Your answer should be very brief. 32.78. What is the difference between the highest and the lowest Persistence rate to the last grade of primary education (%) in Malawi?
Provide a short and direct response. 12.03. 